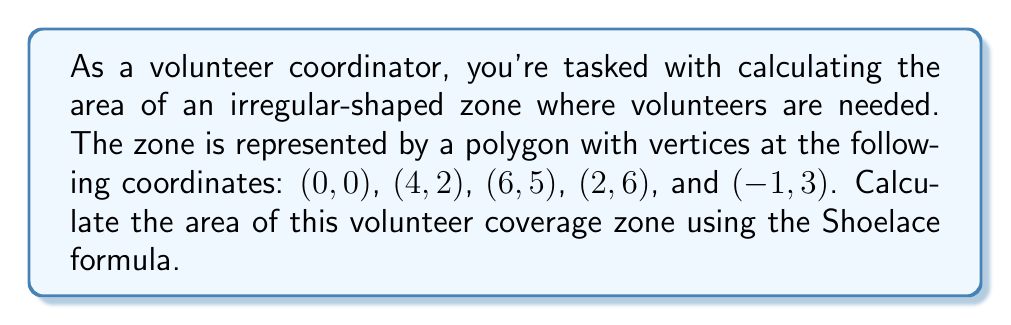Provide a solution to this math problem. To solve this problem, we'll use the Shoelace formula (also known as the surveyor's formula) to calculate the area of the irregular polygon. The formula is:

$$ A = \frac{1}{2} \left| \sum_{i=1}^{n} (x_i y_{i+1} - x_{i+1} y_i) \right| $$

Where $(x_i, y_i)$ are the coordinates of the vertices, and $(x_{n+1}, y_{n+1}) = (x_1, y_1)$.

Let's apply this formula to our polygon:

1. List the coordinates in order:
   $(x_1, y_1) = (0, 0)$
   $(x_2, y_2) = (4, 2)$
   $(x_3, y_3) = (6, 5)$
   $(x_4, y_4) = (2, 6)$
   $(x_5, y_5) = (-1, 3)$
   $(x_6, y_6) = (x_1, y_1) = (0, 0)$ (repeat the first point to close the polygon)

2. Calculate each term in the sum:
   $0 \cdot 2 - 4 \cdot 0 = 0$
   $4 \cdot 5 - 6 \cdot 2 = 8$
   $6 \cdot 6 - 2 \cdot 5 = 26$
   $2 \cdot 3 - (-1) \cdot 6 = 12$
   $(-1) \cdot 0 - 0 \cdot 3 = 0$

3. Sum the terms:
   $0 + 8 + 26 + 12 + 0 = 46$

4. Take the absolute value and divide by 2:
   $\frac{1}{2} |46| = 23$

Therefore, the area of the volunteer coverage zone is 23 square units.

[asy]
unitsize(20);
draw((0,0)--(4,2)--(6,5)--(2,6)--(-1,3)--cycle);
dot((0,0)); dot((4,2)); dot((6,5)); dot((2,6)); dot((-1,3));
label("(0,0)", (0,0), SW);
label("(4,2)", (4,2), SE);
label("(6,5)", (6,5), NE);
label("(2,6)", (2,6), N);
label("(-1,3)", (-1,3), NW);
[/asy]
Answer: The area of the irregular-shaped volunteer coverage zone is 23 square units. 